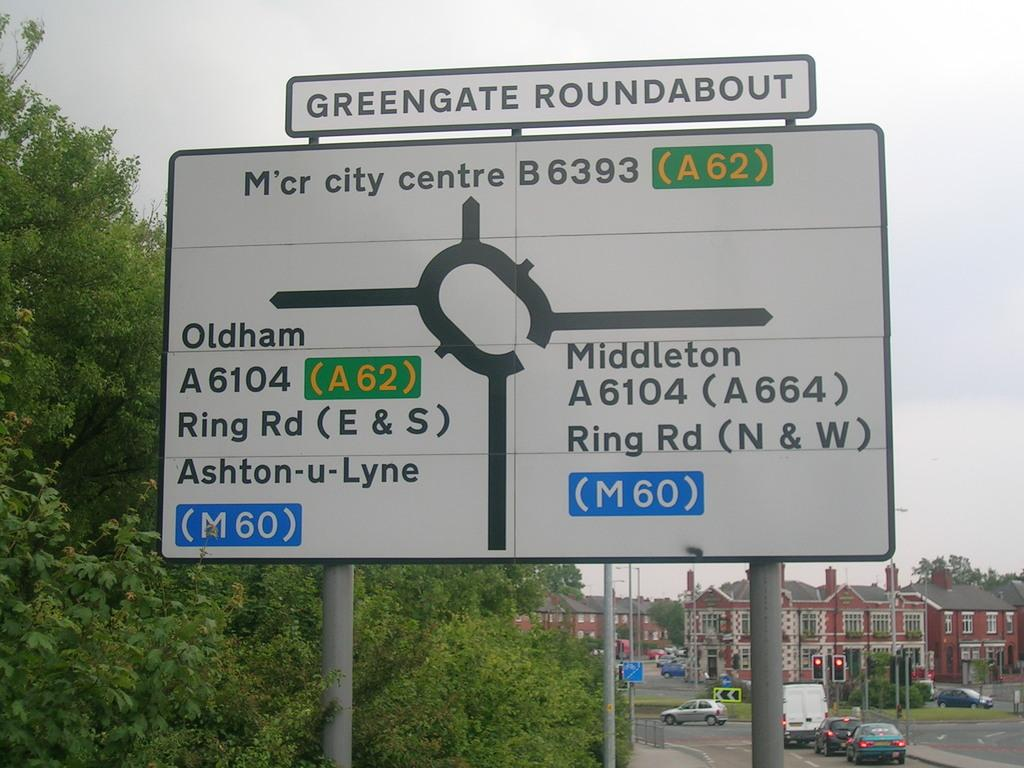<image>
Describe the image concisely. A sign for the Greengate Roundabout shows a complicated diagram of the circle. 